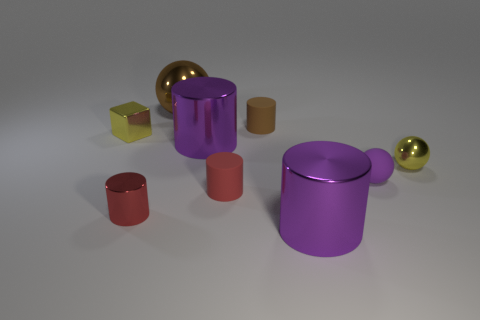Subtract all brown matte cylinders. How many cylinders are left? 4 Subtract all gray spheres. How many red cylinders are left? 2 Subtract 1 spheres. How many spheres are left? 2 Subtract all purple cylinders. How many cylinders are left? 3 Subtract all spheres. How many objects are left? 6 Subtract all big shiny balls. Subtract all large rubber blocks. How many objects are left? 8 Add 8 red objects. How many red objects are left? 10 Add 2 shiny cylinders. How many shiny cylinders exist? 5 Subtract 0 cyan blocks. How many objects are left? 9 Subtract all cyan spheres. Subtract all gray cubes. How many spheres are left? 3 